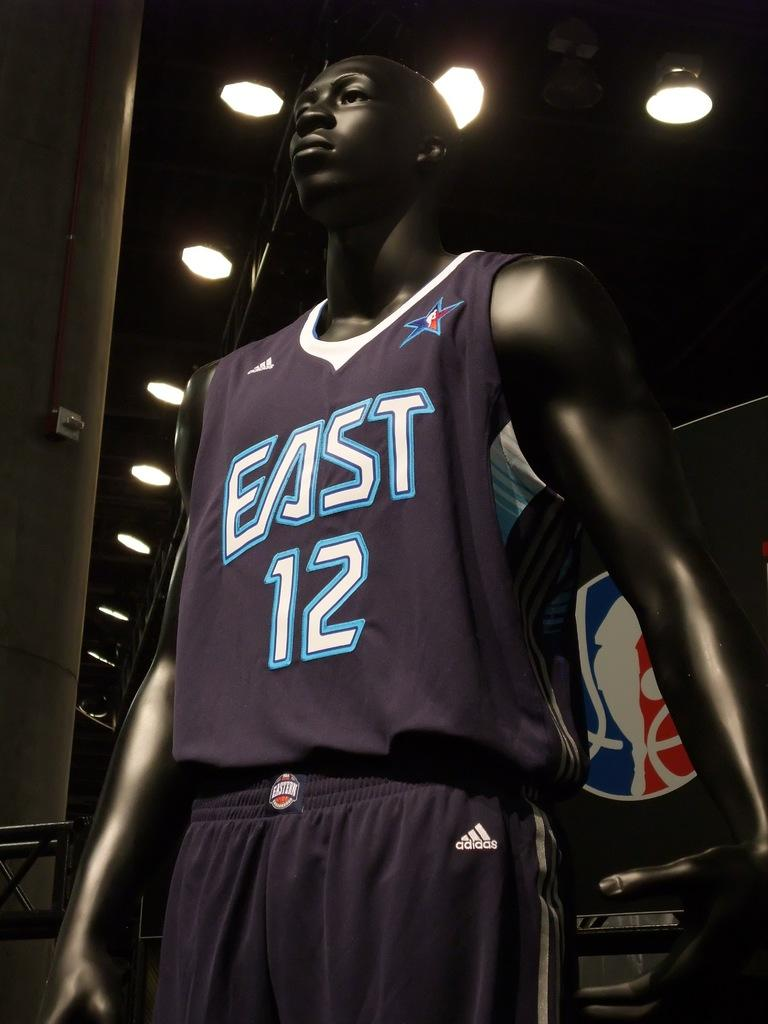<image>
Relay a brief, clear account of the picture shown. A black manequin is wearing a basketball uniform for the east twelve. 